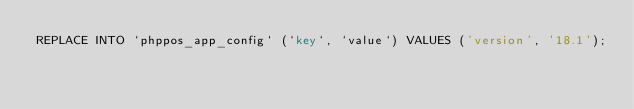<code> <loc_0><loc_0><loc_500><loc_500><_SQL_>REPLACE INTO `phppos_app_config` (`key`, `value`) VALUES ('version', '18.1');</code> 